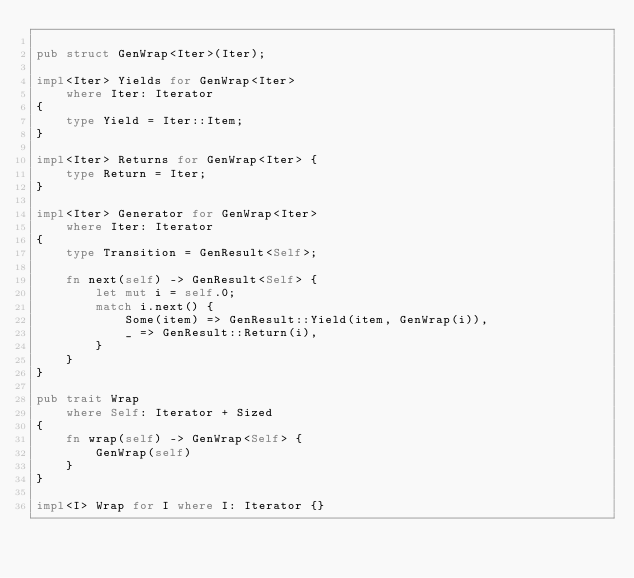Convert code to text. <code><loc_0><loc_0><loc_500><loc_500><_Rust_>
pub struct GenWrap<Iter>(Iter);

impl<Iter> Yields for GenWrap<Iter>
    where Iter: Iterator
{
    type Yield = Iter::Item;
}

impl<Iter> Returns for GenWrap<Iter> {
    type Return = Iter;
}

impl<Iter> Generator for GenWrap<Iter>
    where Iter: Iterator
{
    type Transition = GenResult<Self>;

    fn next(self) -> GenResult<Self> {
        let mut i = self.0;
        match i.next() {
            Some(item) => GenResult::Yield(item, GenWrap(i)),
            _ => GenResult::Return(i),
        }
    }
}

pub trait Wrap
    where Self: Iterator + Sized
{
    fn wrap(self) -> GenWrap<Self> {
        GenWrap(self)
    }
}

impl<I> Wrap for I where I: Iterator {}
</code> 